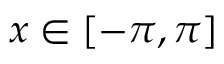Convert formula to latex. <formula><loc_0><loc_0><loc_500><loc_500>x \in [ - \pi , \pi ]</formula> 